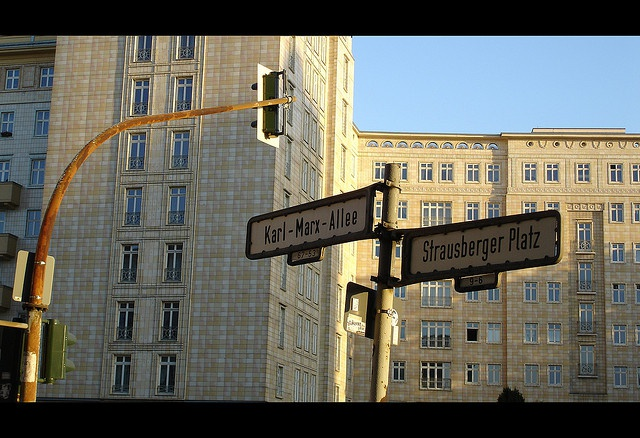Describe the objects in this image and their specific colors. I can see traffic light in black, beige, gray, and tan tones and traffic light in black, darkgreen, and gray tones in this image. 